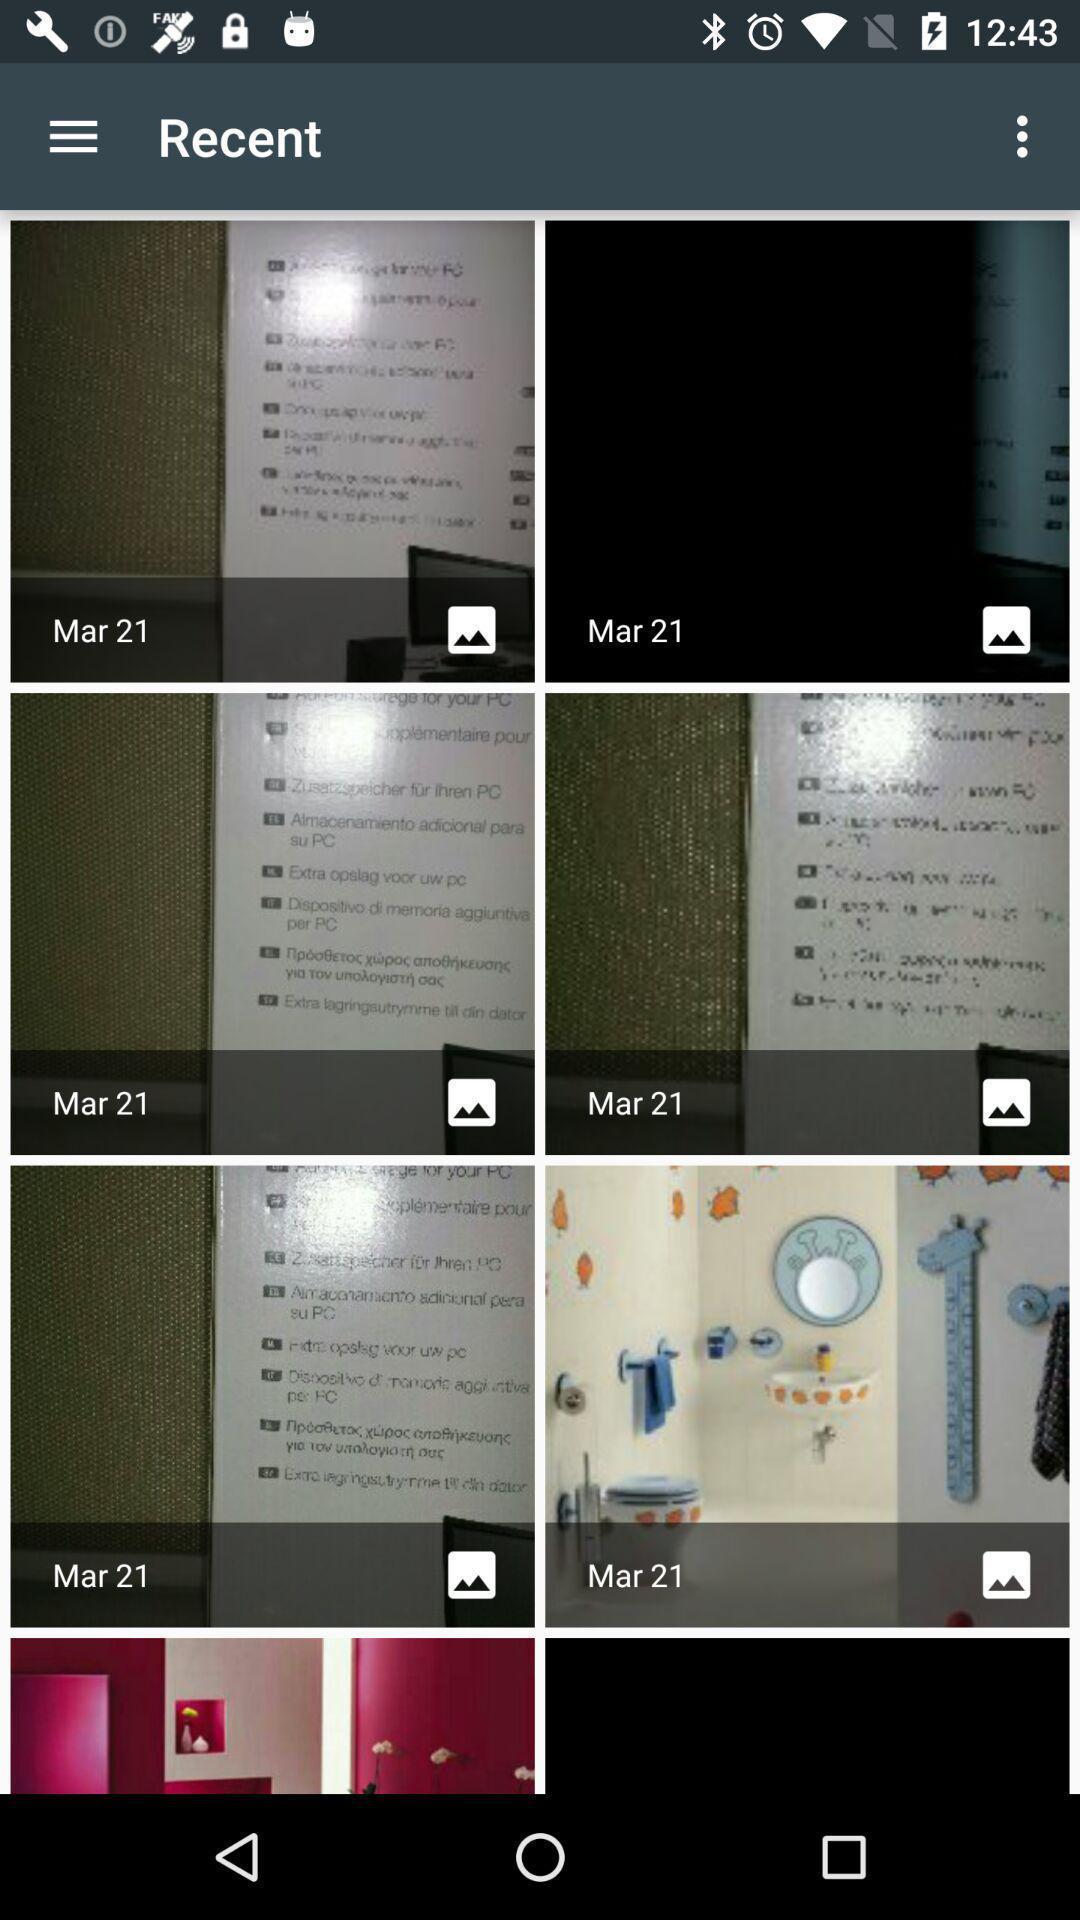Describe the visual elements of this screenshot. Page showing list of images. 